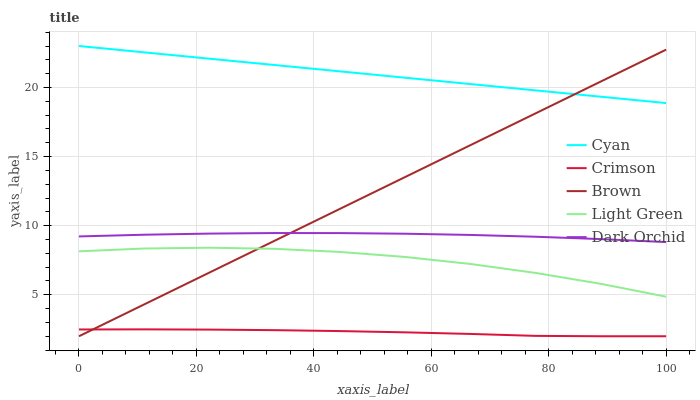Does Crimson have the minimum area under the curve?
Answer yes or no. Yes. Does Cyan have the maximum area under the curve?
Answer yes or no. Yes. Does Dark Orchid have the minimum area under the curve?
Answer yes or no. No. Does Dark Orchid have the maximum area under the curve?
Answer yes or no. No. Is Brown the smoothest?
Answer yes or no. Yes. Is Light Green the roughest?
Answer yes or no. Yes. Is Cyan the smoothest?
Answer yes or no. No. Is Cyan the roughest?
Answer yes or no. No. Does Crimson have the lowest value?
Answer yes or no. Yes. Does Dark Orchid have the lowest value?
Answer yes or no. No. Does Cyan have the highest value?
Answer yes or no. Yes. Does Dark Orchid have the highest value?
Answer yes or no. No. Is Dark Orchid less than Cyan?
Answer yes or no. Yes. Is Light Green greater than Crimson?
Answer yes or no. Yes. Does Dark Orchid intersect Brown?
Answer yes or no. Yes. Is Dark Orchid less than Brown?
Answer yes or no. No. Is Dark Orchid greater than Brown?
Answer yes or no. No. Does Dark Orchid intersect Cyan?
Answer yes or no. No. 